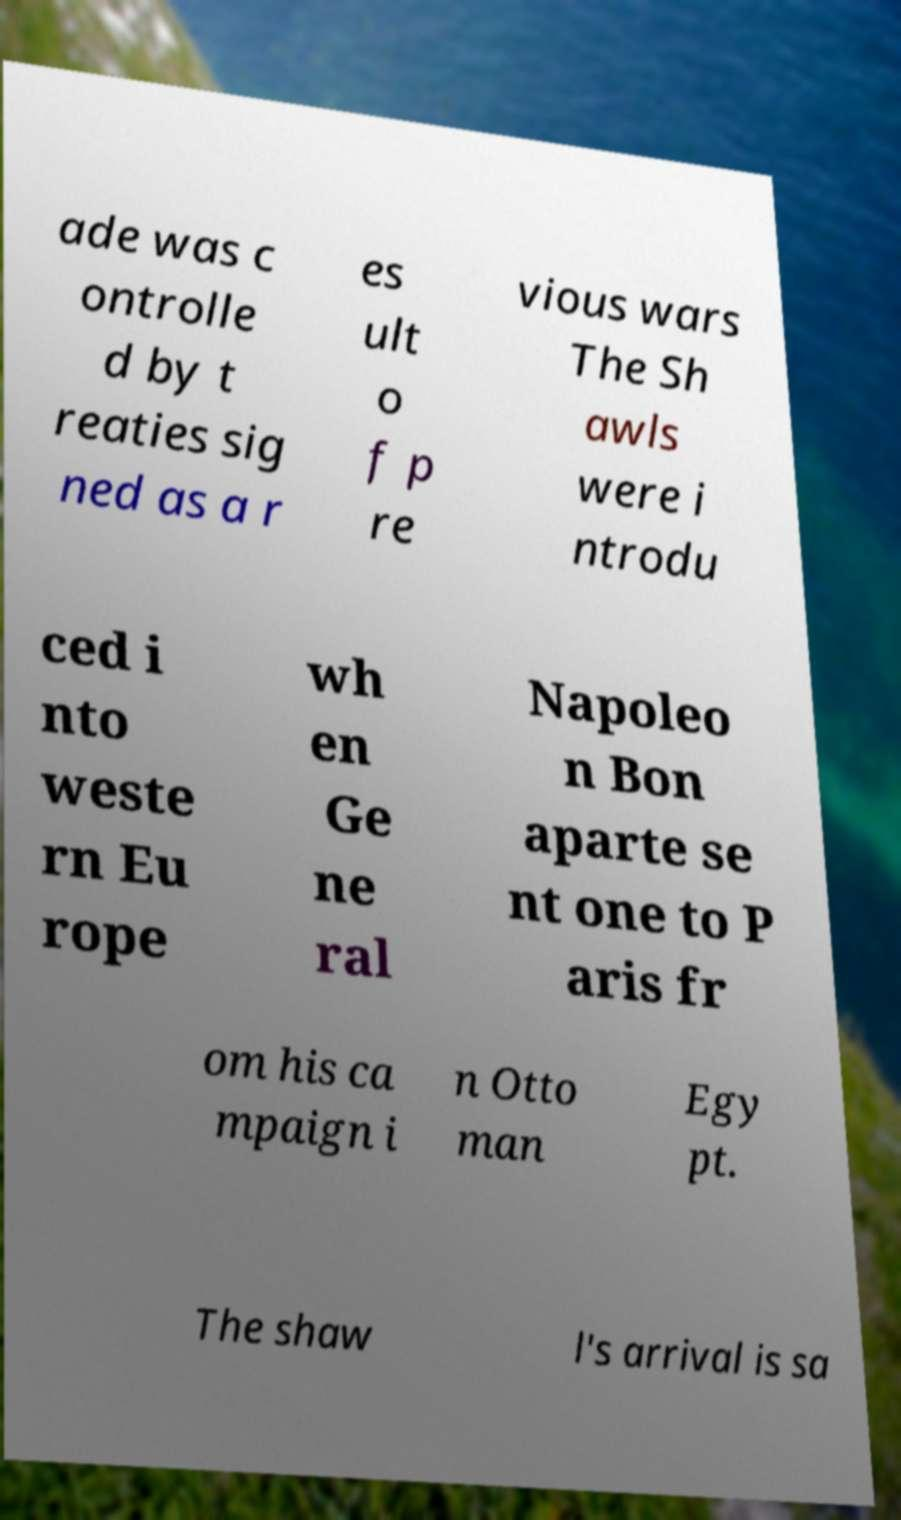Please read and relay the text visible in this image. What does it say? ade was c ontrolle d by t reaties sig ned as a r es ult o f p re vious wars The Sh awls were i ntrodu ced i nto weste rn Eu rope wh en Ge ne ral Napoleo n Bon aparte se nt one to P aris fr om his ca mpaign i n Otto man Egy pt. The shaw l's arrival is sa 